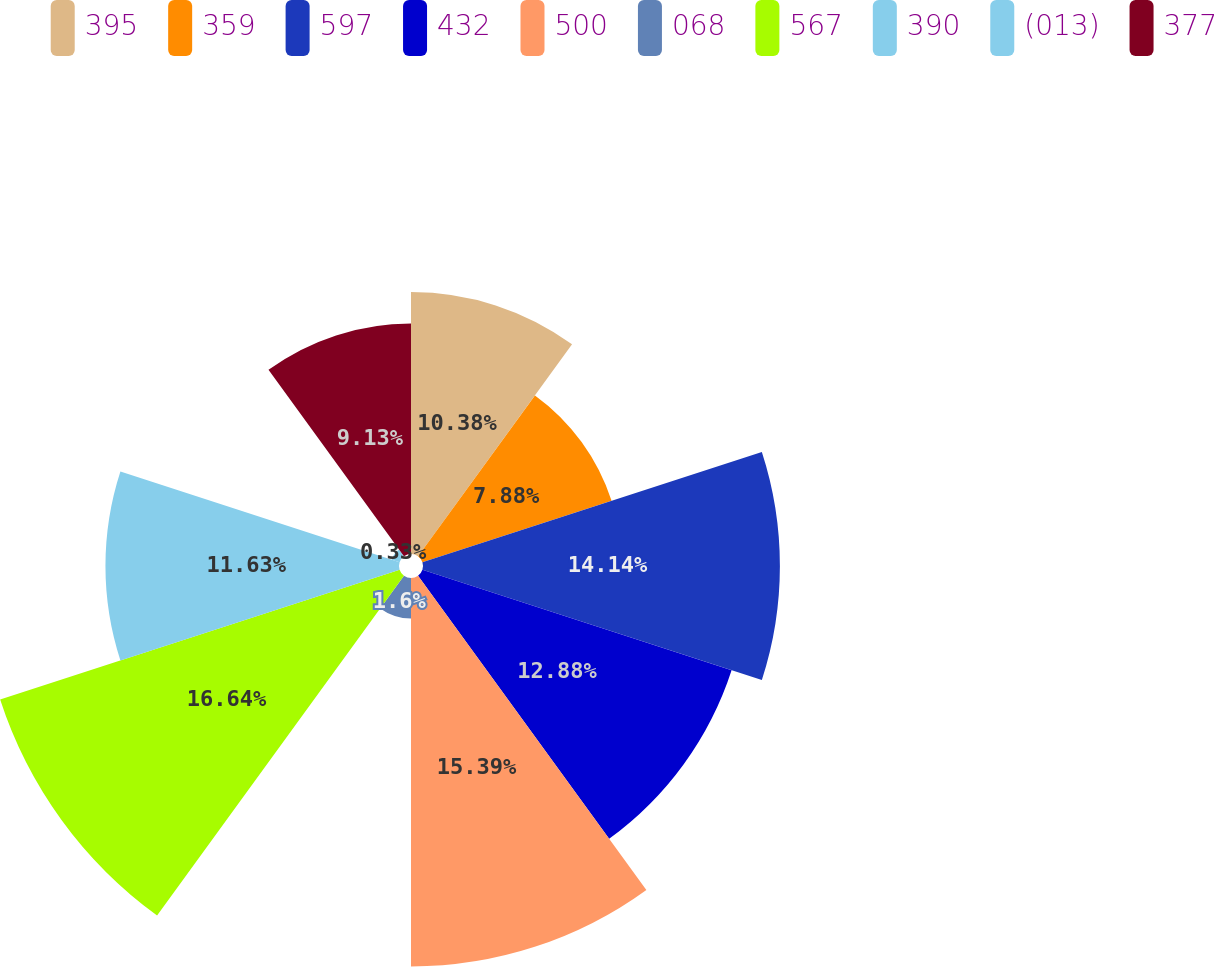Convert chart. <chart><loc_0><loc_0><loc_500><loc_500><pie_chart><fcel>395<fcel>359<fcel>597<fcel>432<fcel>500<fcel>068<fcel>567<fcel>390<fcel>(013)<fcel>377<nl><fcel>10.38%<fcel>7.88%<fcel>14.14%<fcel>12.88%<fcel>15.39%<fcel>1.6%<fcel>16.64%<fcel>11.63%<fcel>0.33%<fcel>9.13%<nl></chart> 